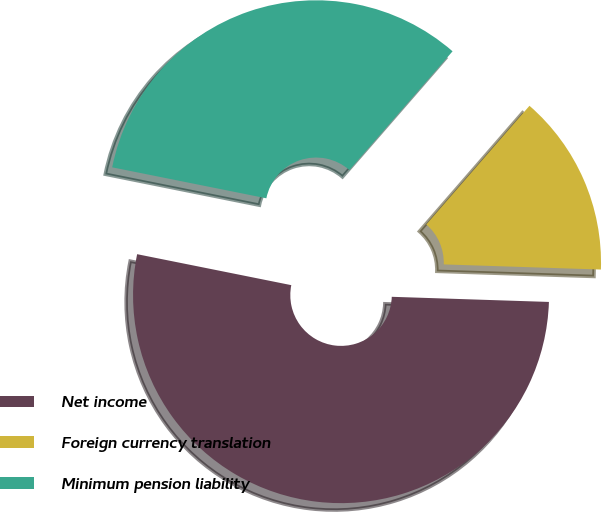<chart> <loc_0><loc_0><loc_500><loc_500><pie_chart><fcel>Net income<fcel>Foreign currency translation<fcel>Minimum pension liability<nl><fcel>52.63%<fcel>14.13%<fcel>33.23%<nl></chart> 